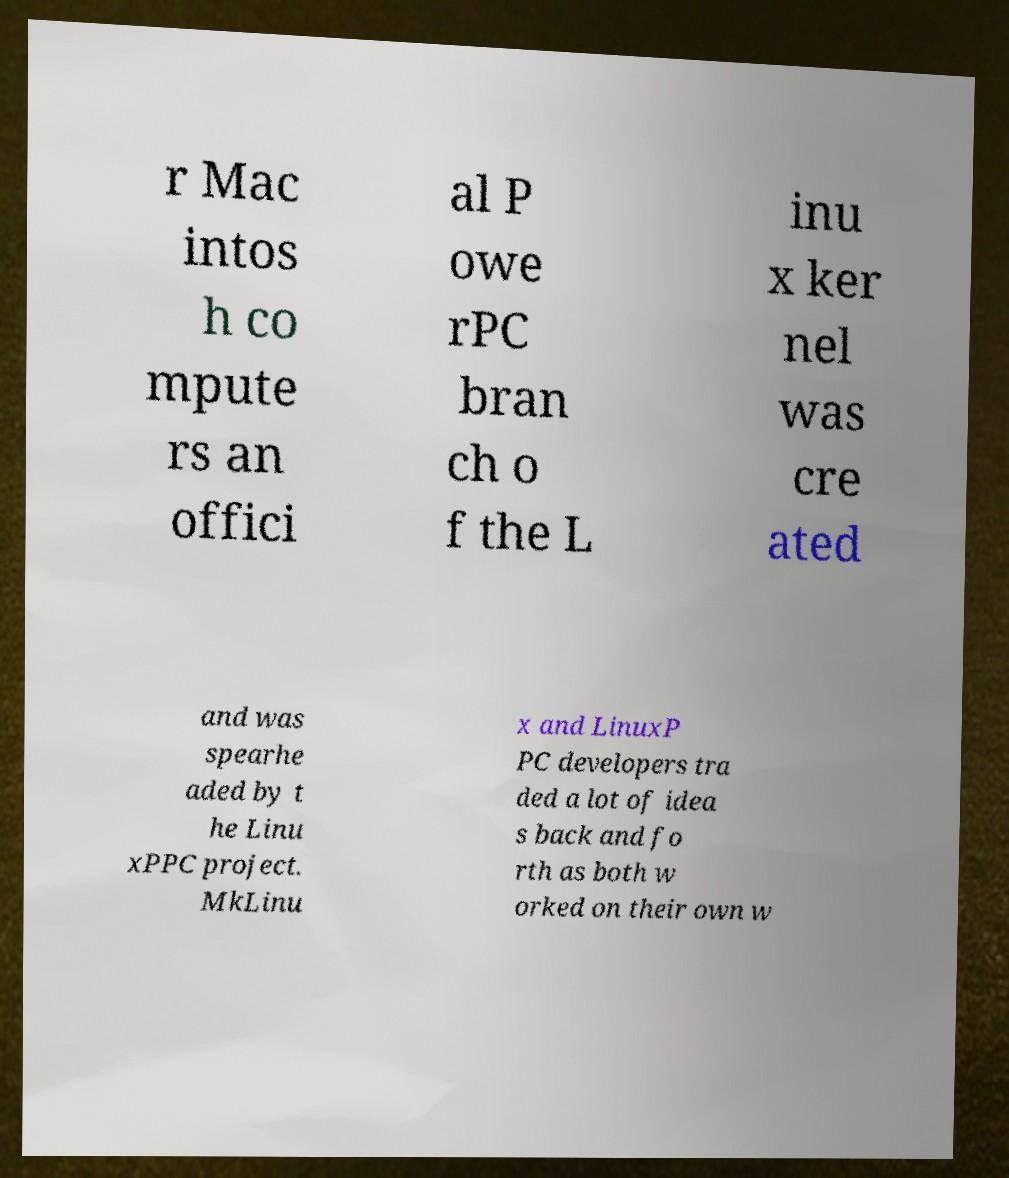Please read and relay the text visible in this image. What does it say? r Mac intos h co mpute rs an offici al P owe rPC bran ch o f the L inu x ker nel was cre ated and was spearhe aded by t he Linu xPPC project. MkLinu x and LinuxP PC developers tra ded a lot of idea s back and fo rth as both w orked on their own w 